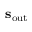Convert formula to latex. <formula><loc_0><loc_0><loc_500><loc_500>s _ { o u t }</formula> 